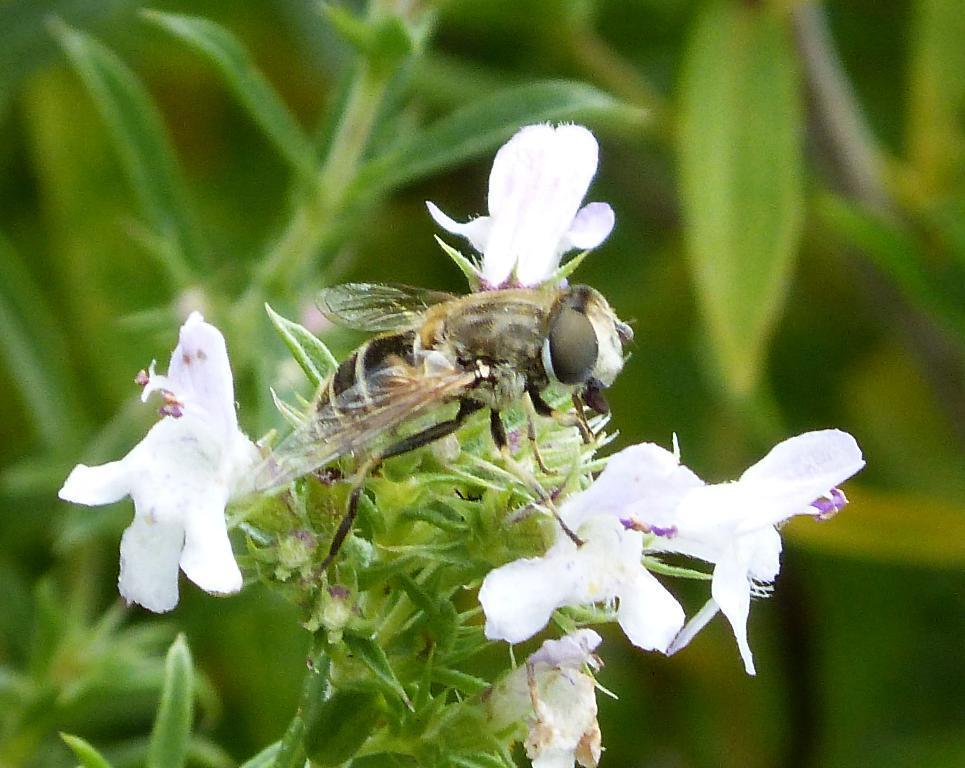Please provide a concise description of this image. In this picture I can see a plant with white flowers, there is an insect on the plant, and there is blur background. 